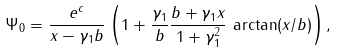Convert formula to latex. <formula><loc_0><loc_0><loc_500><loc_500>\Psi _ { 0 } = \frac { e ^ { c } } { x - \gamma _ { 1 } b } \left ( 1 + \frac { \gamma _ { 1 } } { b } \frac { b + \gamma _ { 1 } x } { 1 + \gamma _ { 1 } ^ { 2 } } \, \arctan ( x / b ) \right ) ,</formula> 